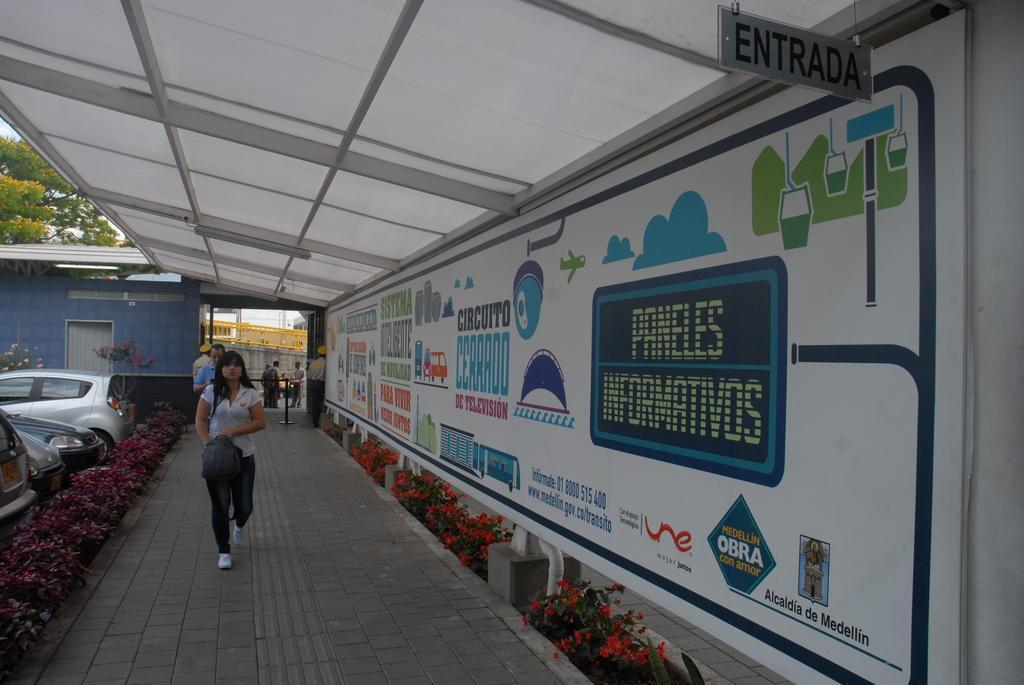Can you describe this image briefly? On the left there are vehicles on the road,plants and there are few people standing here on the ground and a woman is walking on the ground. In the background there is a building,poles,hoarding,trees and sky. 